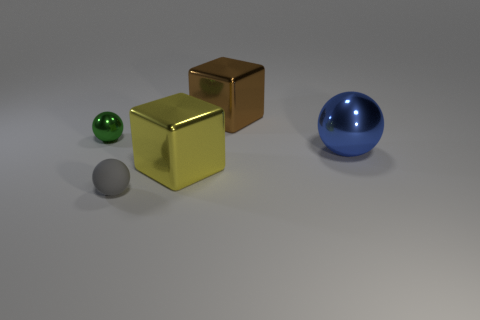Is there a large thing that is to the left of the large thing behind the green thing?
Offer a terse response. Yes. Are the thing behind the small metallic thing and the small green thing made of the same material?
Your answer should be compact. Yes. How many other objects are the same color as the rubber thing?
Make the answer very short. 0. What is the size of the sphere that is on the right side of the object that is in front of the yellow shiny thing?
Offer a very short reply. Large. Does the thing on the left side of the small matte ball have the same material as the ball on the right side of the tiny rubber object?
Provide a short and direct response. Yes. What number of green objects are in front of the yellow metal cube?
Give a very brief answer. 0. Is the yellow cube made of the same material as the ball that is on the right side of the gray thing?
Your response must be concise. Yes. There is a green thing that is made of the same material as the big yellow block; what is its size?
Keep it short and to the point. Small. Is the number of things to the right of the gray rubber object greater than the number of matte spheres behind the brown block?
Your answer should be very brief. Yes. Are there any large yellow shiny objects of the same shape as the brown object?
Offer a very short reply. Yes. 